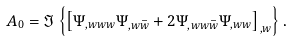Convert formula to latex. <formula><loc_0><loc_0><loc_500><loc_500>A _ { 0 } = \Im \left \{ \left [ \Psi _ { , w w w } \Psi _ { , w \bar { w } } + 2 \Psi _ { , w w \bar { w } } \Psi _ { , w w } \right ] _ { , w } \right \} .</formula> 